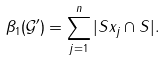<formula> <loc_0><loc_0><loc_500><loc_500>\beta _ { 1 } ( { \mathcal { G } } ^ { \prime } ) = \sum _ { j = 1 } ^ { n } | S x _ { j } \cap S | .</formula> 